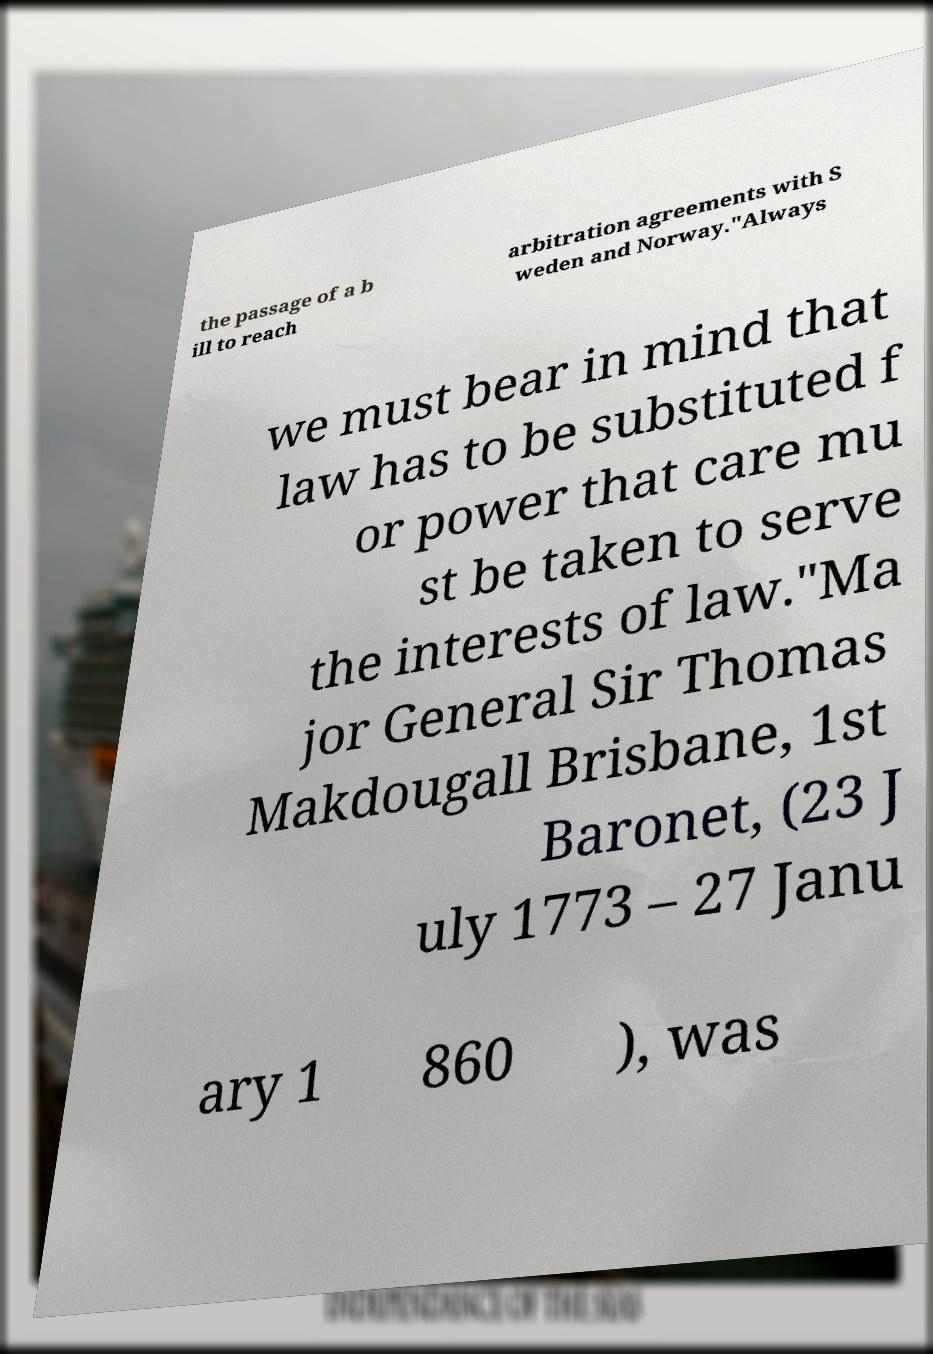There's text embedded in this image that I need extracted. Can you transcribe it verbatim? the passage of a b ill to reach arbitration agreements with S weden and Norway."Always we must bear in mind that law has to be substituted f or power that care mu st be taken to serve the interests of law."Ma jor General Sir Thomas Makdougall Brisbane, 1st Baronet, (23 J uly 1773 – 27 Janu ary 1 860 ), was 